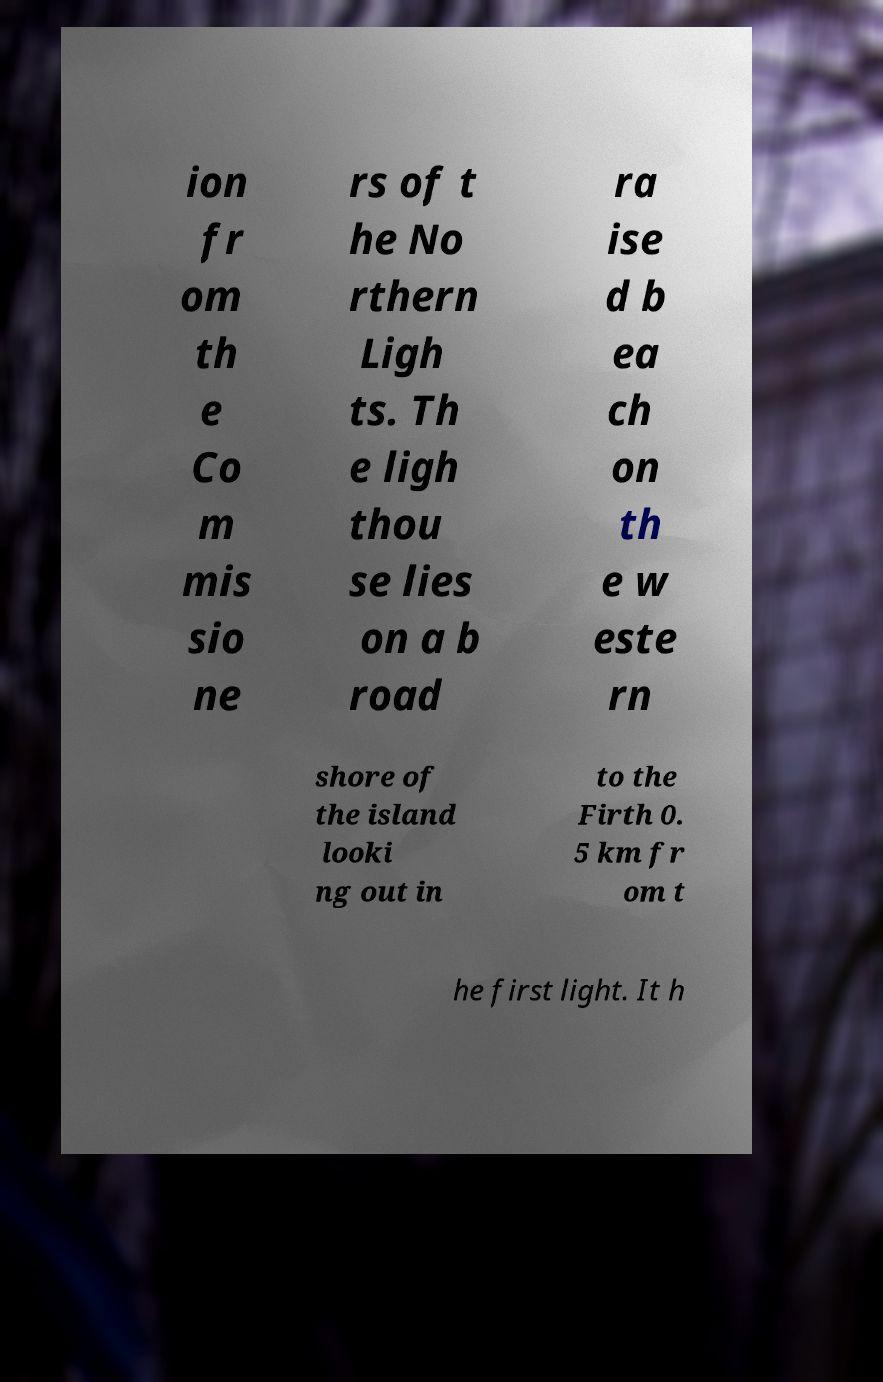Could you extract and type out the text from this image? ion fr om th e Co m mis sio ne rs of t he No rthern Ligh ts. Th e ligh thou se lies on a b road ra ise d b ea ch on th e w este rn shore of the island looki ng out in to the Firth 0. 5 km fr om t he first light. It h 